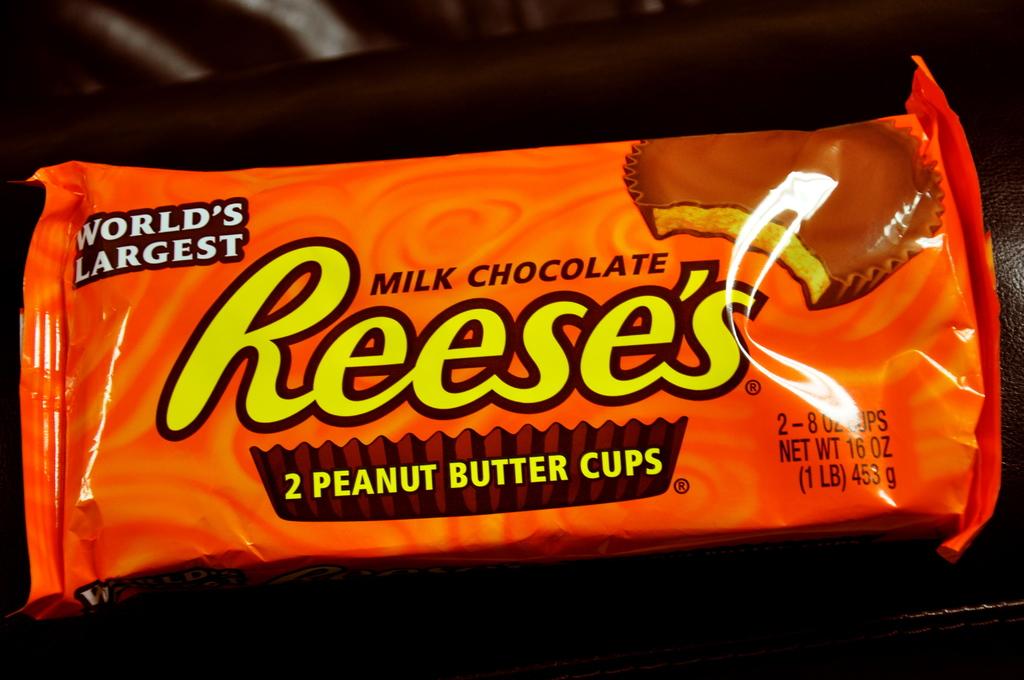What brand of candy is this?
Give a very brief answer. Reese's. 